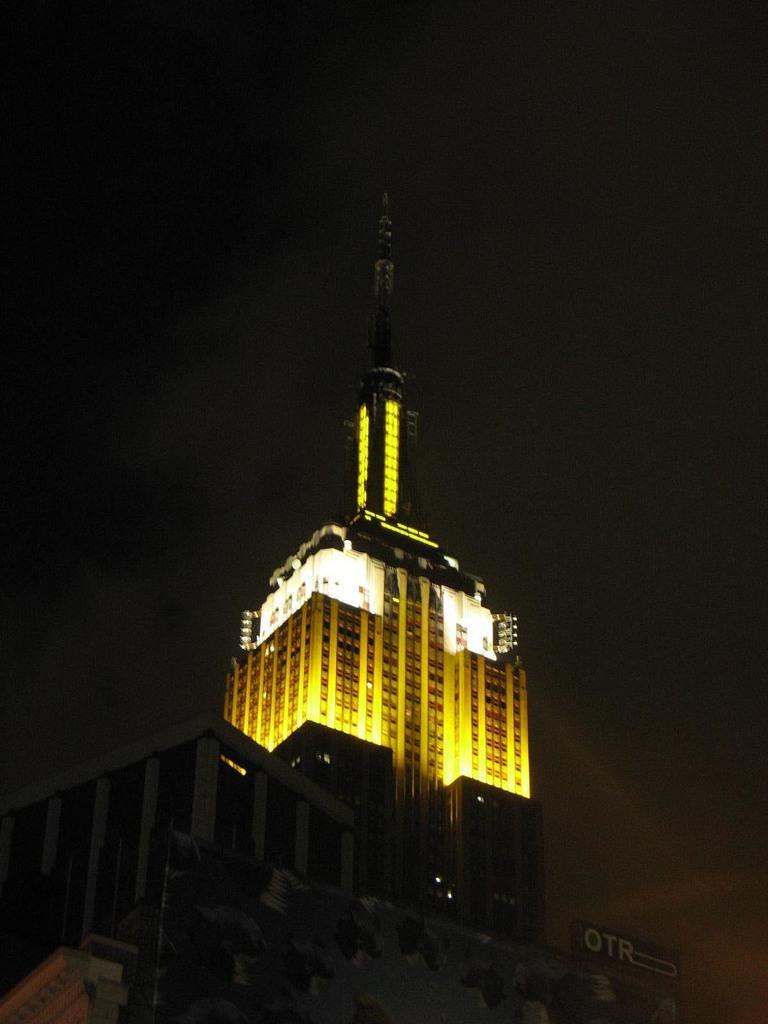Could you give a brief overview of what you see in this image? In this image I can see a building with lights. 